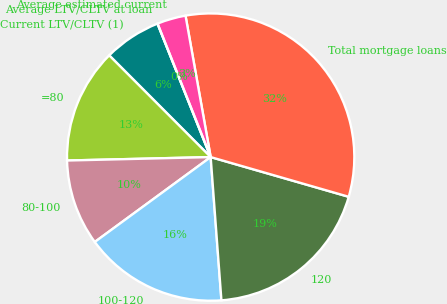<chart> <loc_0><loc_0><loc_500><loc_500><pie_chart><fcel>Current LTV/CLTV (1)<fcel>=80<fcel>80-100<fcel>100-120<fcel>120<fcel>Total mortgage loans<fcel>Average estimated current<fcel>Average LTV/CLTV at loan<nl><fcel>6.45%<fcel>12.9%<fcel>9.68%<fcel>16.13%<fcel>19.35%<fcel>32.26%<fcel>3.23%<fcel>0.0%<nl></chart> 